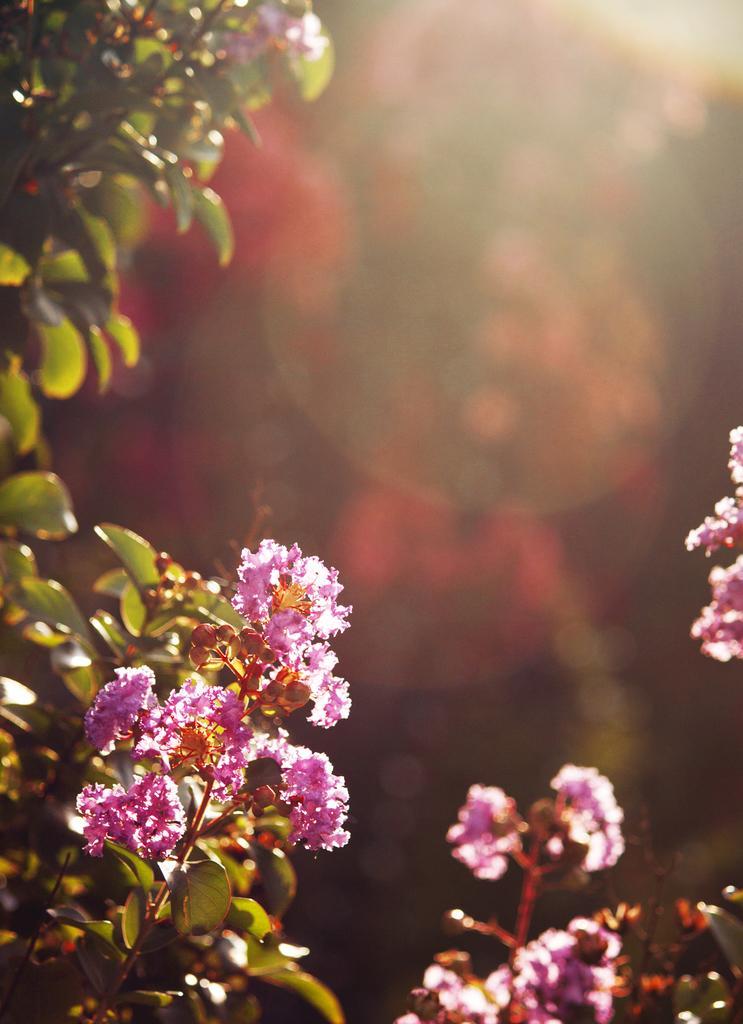How would you summarize this image in a sentence or two? As we can see in the image there are plants and flowers. The background is blurred. 